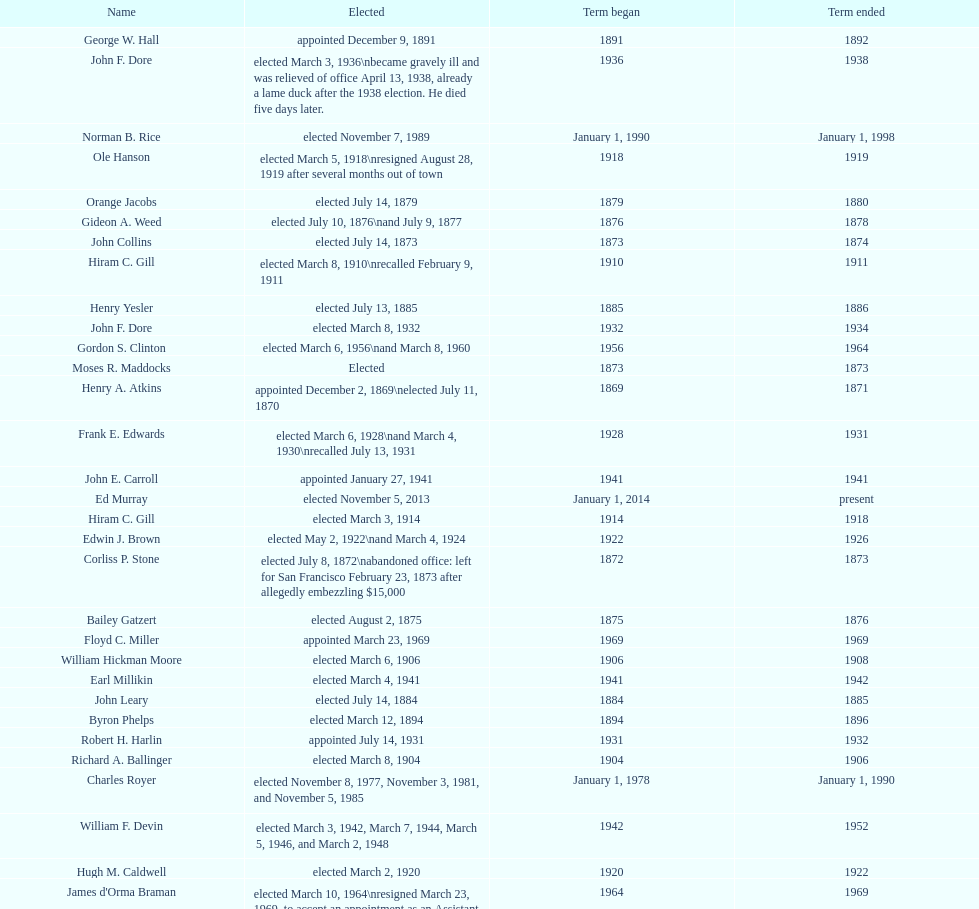Who was the only person elected in 1871? John T. Jordan. 